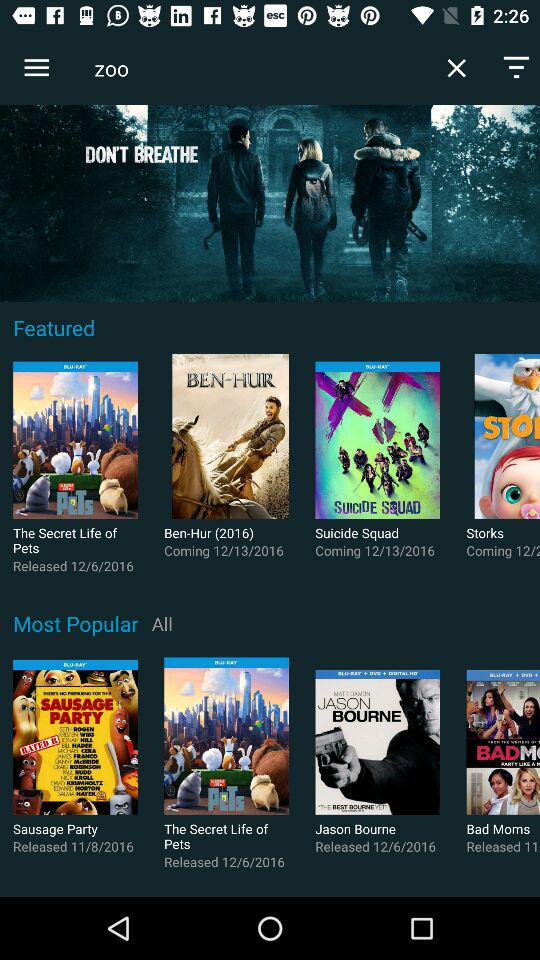When was "The Secret Life of Pets" released? "The Secret Life of Pets" was released on December 6, 2016. 